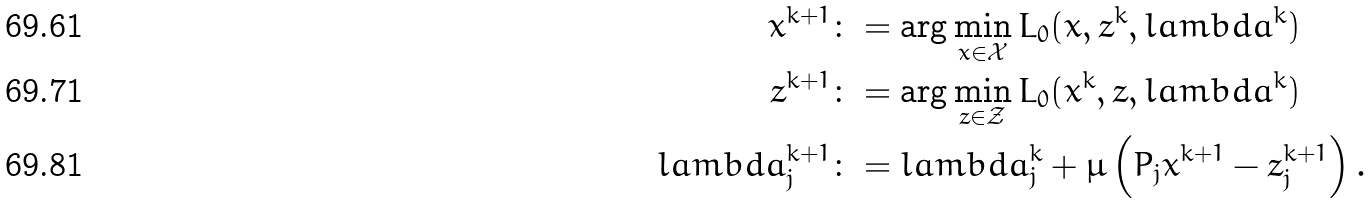Convert formula to latex. <formula><loc_0><loc_0><loc_500><loc_500>x ^ { k + 1 } & \colon = \arg \min _ { x \in \mathcal { X } } L _ { 0 } ( x , z ^ { k } , l a m b d a ^ { k } ) \\ z ^ { k + 1 } & \colon = \arg \min _ { z \in \mathcal { Z } } L _ { 0 } ( x ^ { k } , z , l a m b d a ^ { k } ) \\ l a m b d a _ { j } ^ { k + 1 } & \colon = l a m b d a _ { j } ^ { k } + \mu \left ( P _ { j } x ^ { k + 1 } - z _ { j } ^ { k + 1 } \right ) .</formula> 